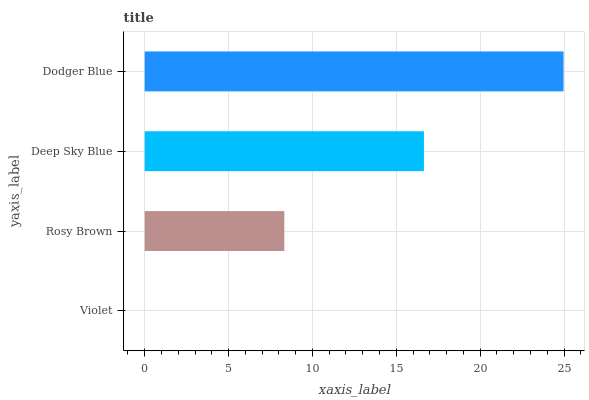Is Violet the minimum?
Answer yes or no. Yes. Is Dodger Blue the maximum?
Answer yes or no. Yes. Is Rosy Brown the minimum?
Answer yes or no. No. Is Rosy Brown the maximum?
Answer yes or no. No. Is Rosy Brown greater than Violet?
Answer yes or no. Yes. Is Violet less than Rosy Brown?
Answer yes or no. Yes. Is Violet greater than Rosy Brown?
Answer yes or no. No. Is Rosy Brown less than Violet?
Answer yes or no. No. Is Deep Sky Blue the high median?
Answer yes or no. Yes. Is Rosy Brown the low median?
Answer yes or no. Yes. Is Violet the high median?
Answer yes or no. No. Is Violet the low median?
Answer yes or no. No. 